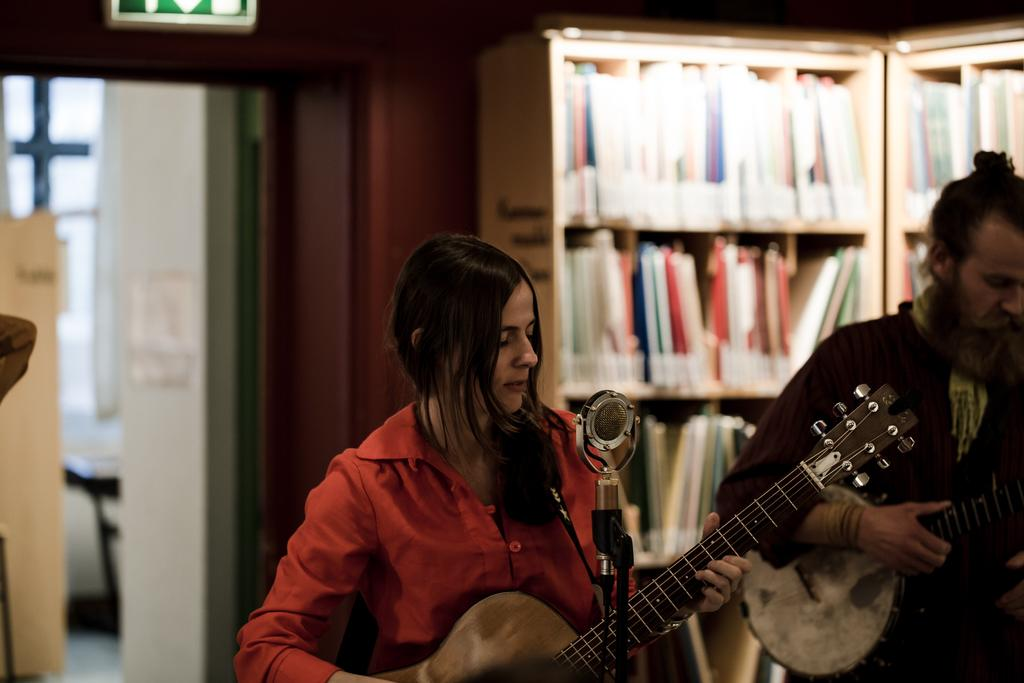How many people are in the image? There are two people in the image, a man and a lady. What are the man and the lady doing in the image? The man is playing a guitar, and the lady is also playing a guitar. What object is present in the image that is typically used for amplifying sound? There is a microphone in the image. What type of setting is depicted in the image? The setting appears to be inside an office. What type of powder is being used by the man and the lady in the image? There is no powder present in the image; the man and the lady are playing guitars. What type of observation is being made by the man and the lady in the image? There is no observation being made by the man and the lady in the image; they are playing guitars. 